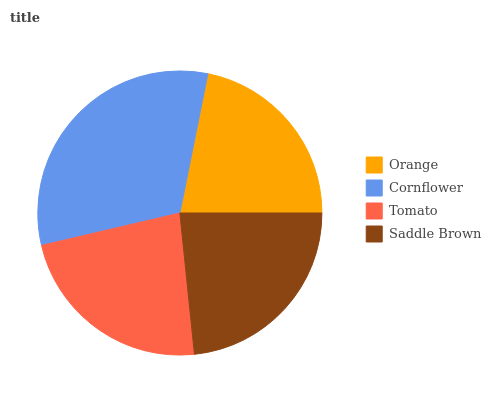Is Orange the minimum?
Answer yes or no. Yes. Is Cornflower the maximum?
Answer yes or no. Yes. Is Tomato the minimum?
Answer yes or no. No. Is Tomato the maximum?
Answer yes or no. No. Is Cornflower greater than Tomato?
Answer yes or no. Yes. Is Tomato less than Cornflower?
Answer yes or no. Yes. Is Tomato greater than Cornflower?
Answer yes or no. No. Is Cornflower less than Tomato?
Answer yes or no. No. Is Saddle Brown the high median?
Answer yes or no. Yes. Is Tomato the low median?
Answer yes or no. Yes. Is Orange the high median?
Answer yes or no. No. Is Cornflower the low median?
Answer yes or no. No. 